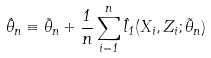Convert formula to latex. <formula><loc_0><loc_0><loc_500><loc_500>\hat { \theta } _ { n } \equiv \tilde { \theta } _ { n } + \frac { 1 } { n } \sum _ { i = 1 } ^ { n } \hat { l } _ { 1 } ( X _ { i } , Z _ { i } ; \tilde { \theta } _ { n } )</formula> 